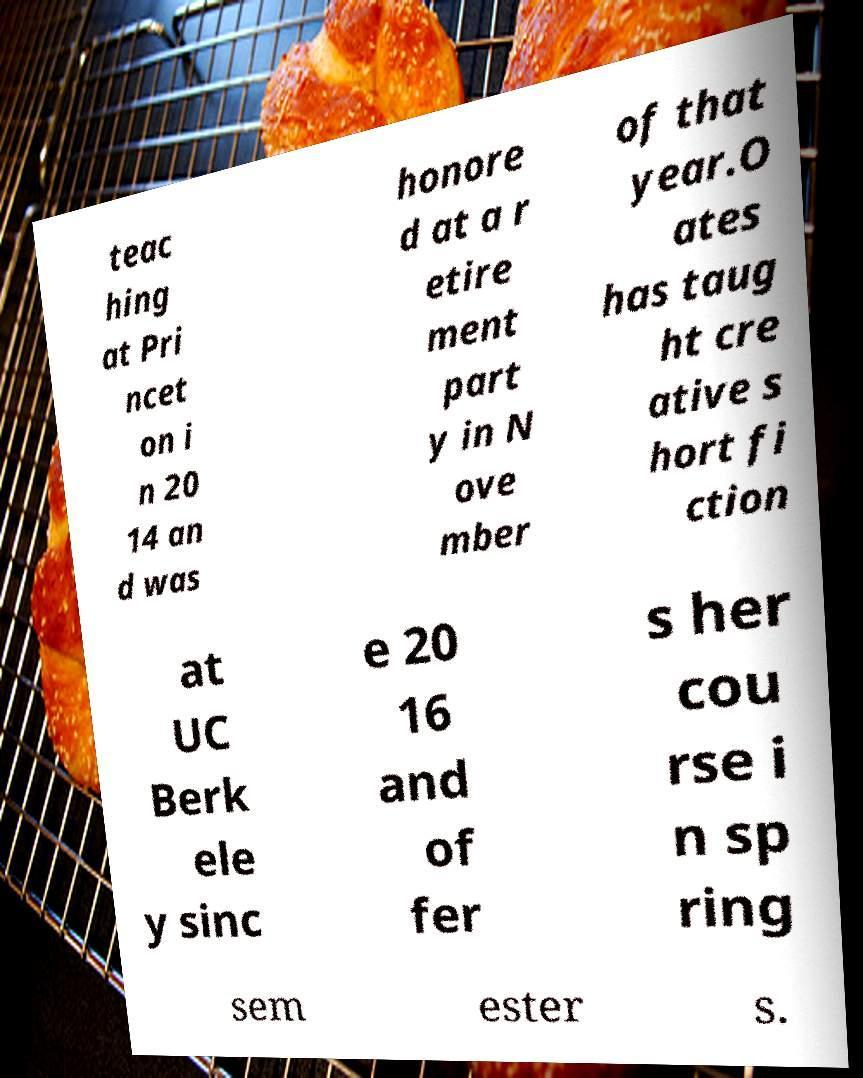There's text embedded in this image that I need extracted. Can you transcribe it verbatim? teac hing at Pri ncet on i n 20 14 an d was honore d at a r etire ment part y in N ove mber of that year.O ates has taug ht cre ative s hort fi ction at UC Berk ele y sinc e 20 16 and of fer s her cou rse i n sp ring sem ester s. 